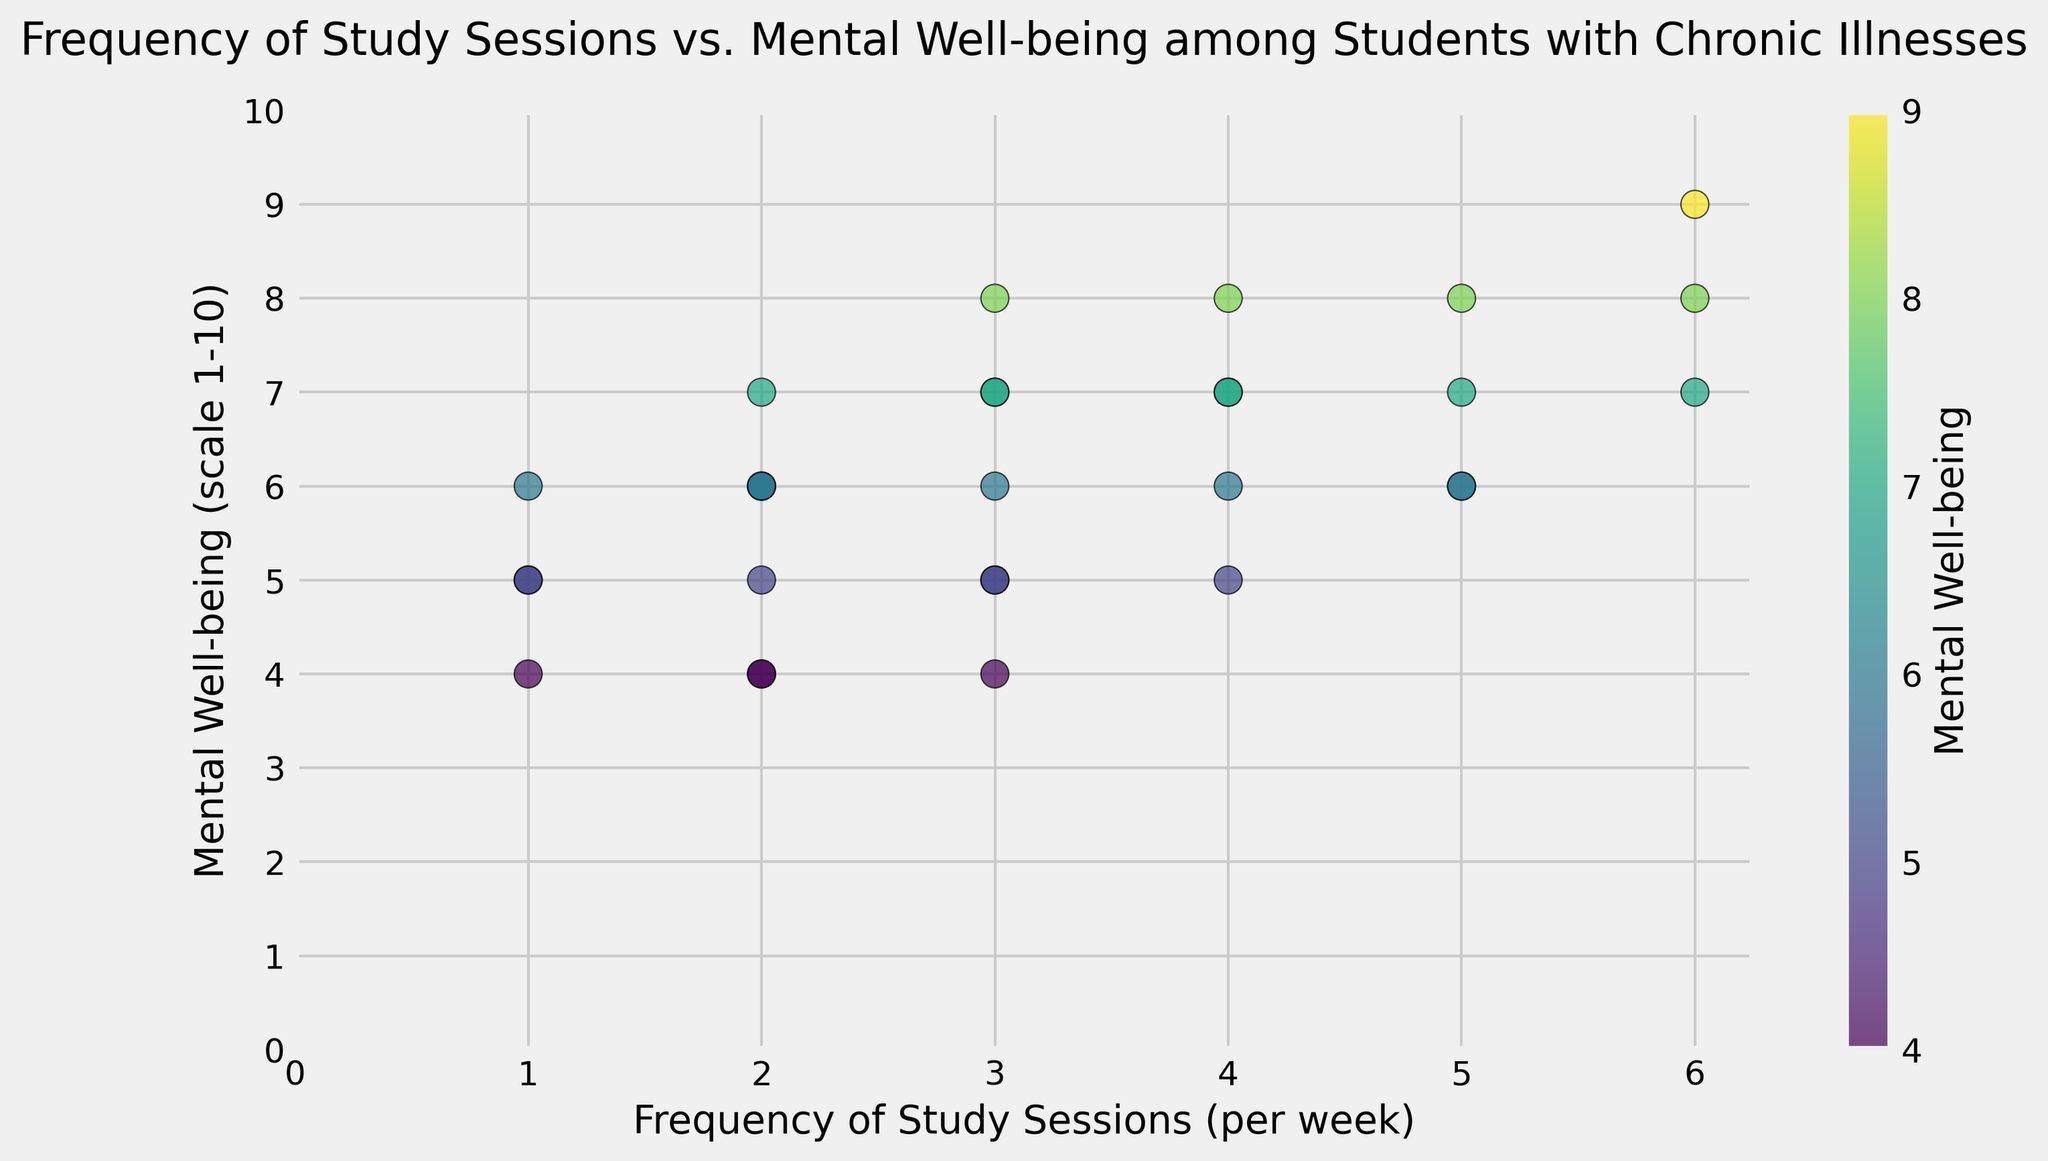What is the general trend between the frequency of study sessions and mental well-being among students with chronic illnesses? The scatter plot shows that as the frequency of study sessions increases, the mental well-being scores tend to increase as well, indicating a positive correlation.
Answer: Positive correlation What is the mental well-being score for students who have 4 study sessions per week? By examining the points along the x-axis at the value of 4, we see that the mental well-being scores are 8, 7, 6, and 5.
Answer: 8, 7, 6, and 5 How many students have a mental well-being score of 6? By counting the points at y=6, we see six students have a mental well-being score of 6.
Answer: 6 students Which frequency of study sessions appears to be associated with the highest mental well-being score? By locating the highest point on the y-axis (score of 9), we see that it corresponds with a frequency of 6 study sessions per week.
Answer: 6 study sessions per week Is there any frequency of study sessions that results in a mental well-being score of 5? By examining the points on y=5, we see that the frequencies are 1, 2, 3, and 4.
Answer: 1, 2, 3, and 4 Among students who study 3 times per week, what is the range of their mental well-being scores? By looking at the points corresponding to x=3, the mental well-being scores are 7, 5, 8, 6, 7, and 4. Therefore, the range is 4 to 8.
Answer: 4 to 8 What is the most frequent mental well-being score for students who study 1 time per week? By examining the points at x=1, we see that the mental well-being scores are 5 (twice), 6, 4, and 5. The score of 5 appears three times.
Answer: 5 How does the mental well-being change between students who study 4 times per week and those who study 5 times per week? By examining the scores for x=4 (8, 7, 6, 5) and for x=5 (6, 7, 8, 7), more students with 5 study sessions have high scores, showing an overall slight increase in mental well-being from 4 to 5 sessions.
Answer: Slight increase What is the average mental well-being score of students who study 2 times per week? The values for x=2 are 4, 6, 7, 5, 6, and 4. Sum these up to get 32. Dividing 32 by the number of values (6), we get an average of approximately 5.33.
Answer: ~5.33 Are there more students with a mental well-being score above or below 6? By counting the points, there are 12 scores above 6 (7-9) and 18 scores 6 or below.
Answer: More students have scores 6 or below 